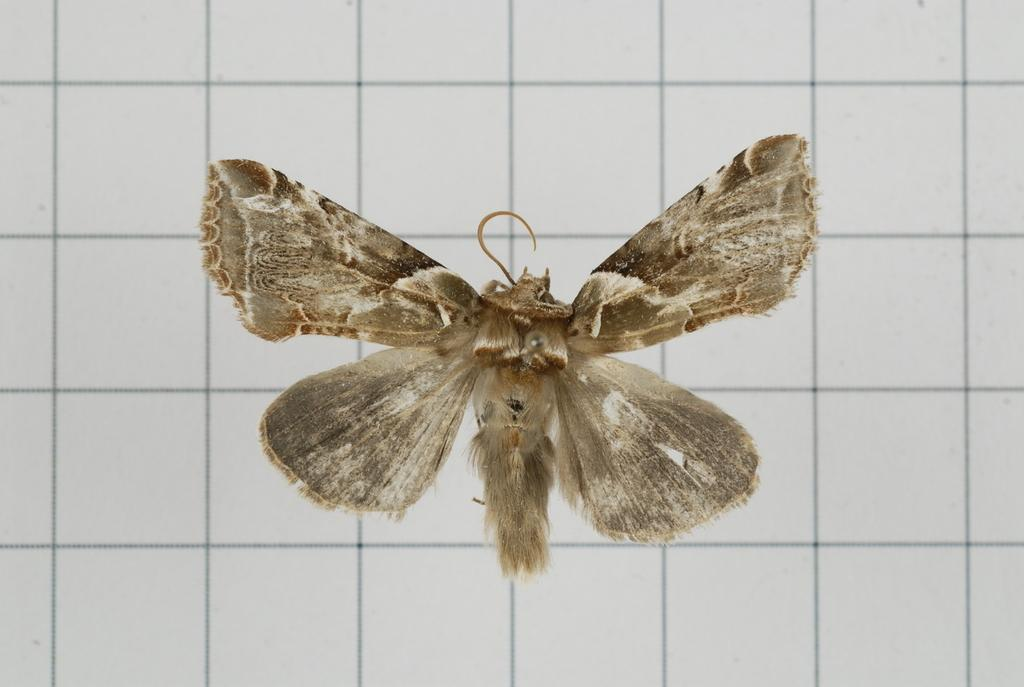What type of creature is present in the image? There is an insect in the image. What is the insect situated on in the image? The insect is on a graph-like paper. Where is the insect and the paper located in the image? The insect and the paper are in the center of the image. Can you tell me how many fish are swimming in the image? There are no fish present in the image; it features an insect on a graph-like paper. What type of doll is visible in the image? There is no doll present in the image. 